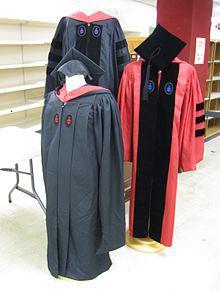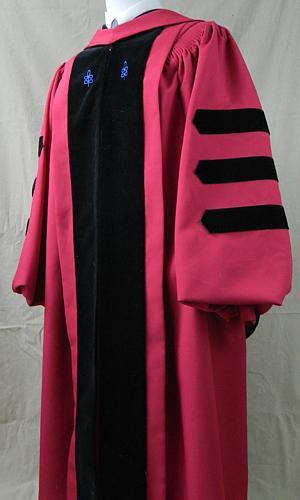The first image is the image on the left, the second image is the image on the right. For the images shown, is this caption "There are two pink gowns with three horizontal black stripes on the sleeve." true? Answer yes or no. Yes. The first image is the image on the left, the second image is the image on the right. Assess this claim about the two images: "One image shows a human male with facial hair modeling a tasseled cap and a robe with three stripes per sleeve.". Correct or not? Answer yes or no. No. 